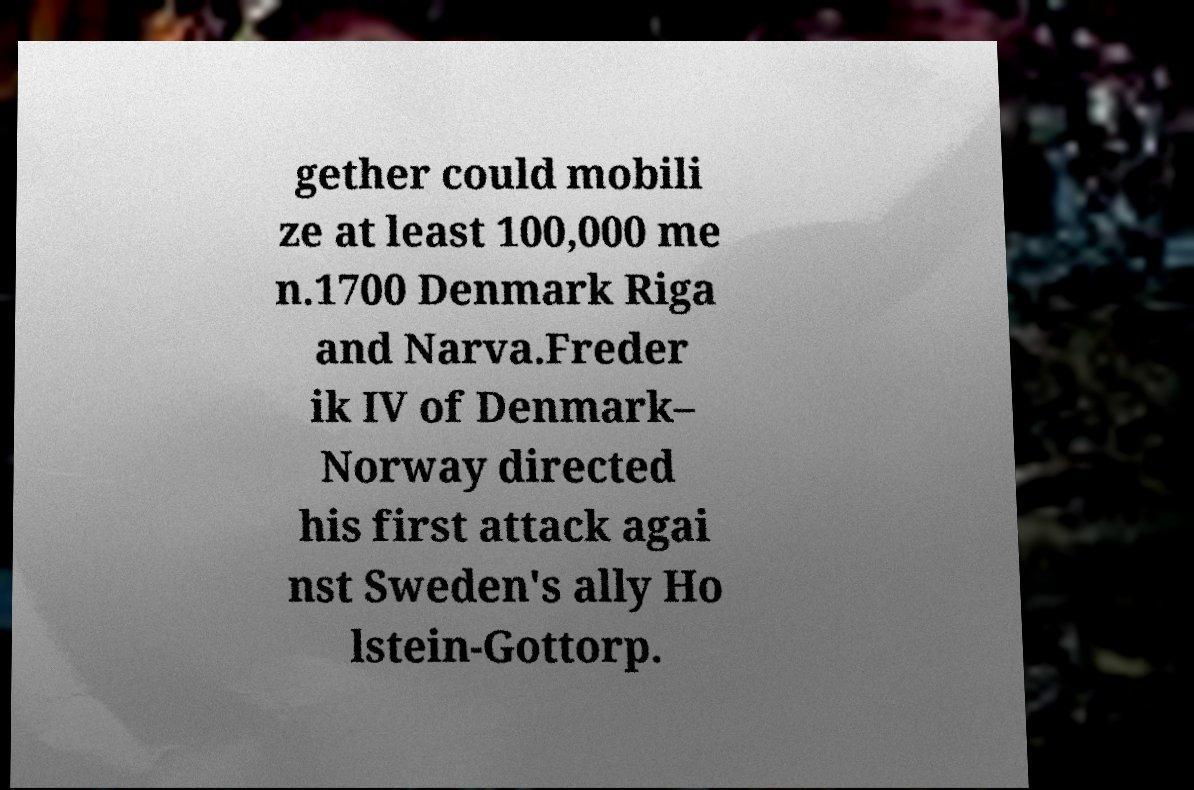Could you extract and type out the text from this image? gether could mobili ze at least 100,000 me n.1700 Denmark Riga and Narva.Freder ik IV of Denmark– Norway directed his first attack agai nst Sweden's ally Ho lstein-Gottorp. 